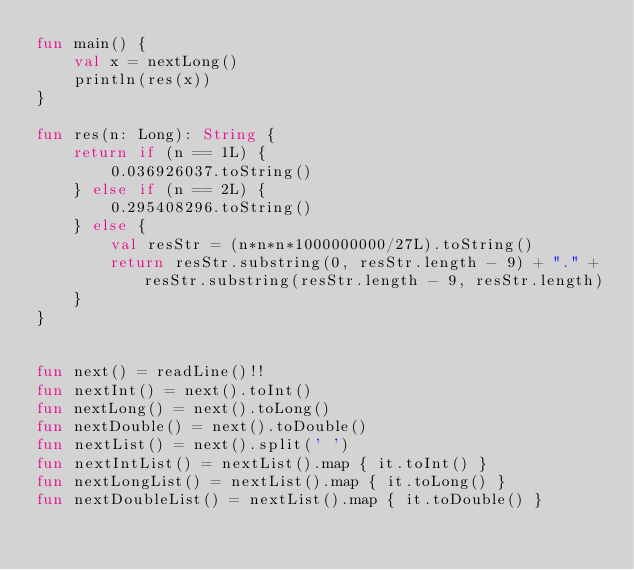<code> <loc_0><loc_0><loc_500><loc_500><_Kotlin_>fun main() {
    val x = nextLong()
    println(res(x))
}

fun res(n: Long): String {
    return if (n == 1L) {
        0.036926037.toString()
    } else if (n == 2L) {
        0.295408296.toString()
    } else {
        val resStr = (n*n*n*1000000000/27L).toString()
        return resStr.substring(0, resStr.length - 9) + "." + resStr.substring(resStr.length - 9, resStr.length)
    }
}


fun next() = readLine()!!
fun nextInt() = next().toInt()
fun nextLong() = next().toLong()
fun nextDouble() = next().toDouble()
fun nextList() = next().split(' ')
fun nextIntList() = nextList().map { it.toInt() }
fun nextLongList() = nextList().map { it.toLong() }
fun nextDoubleList() = nextList().map { it.toDouble() }
</code> 